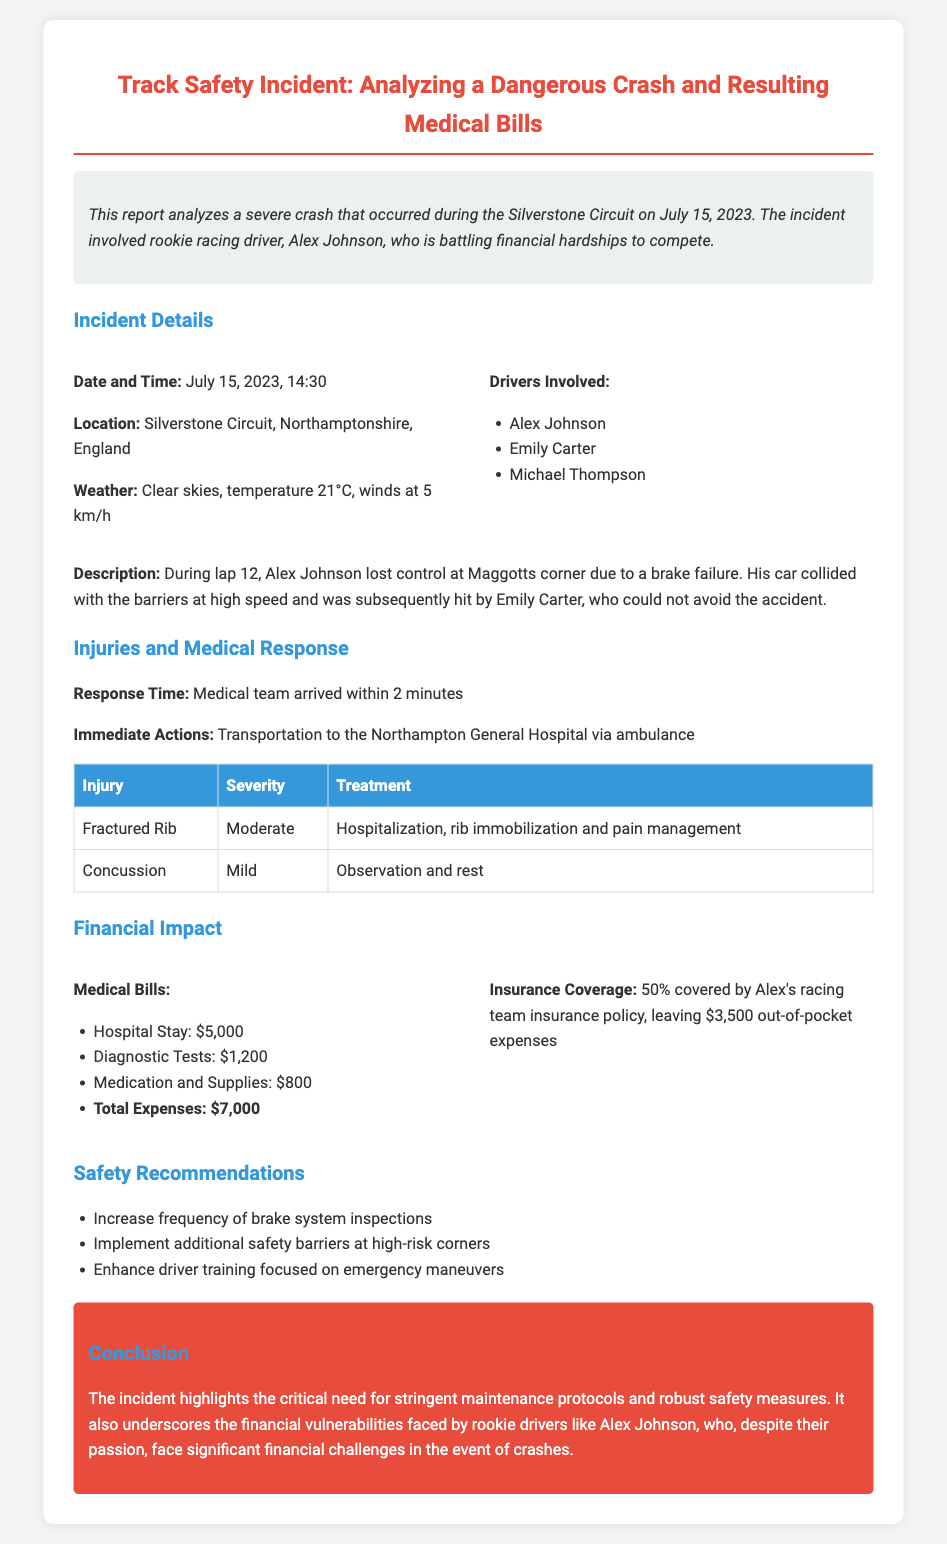What date did the incident occur? The incident took place on July 15, 2023, as stated in the document.
Answer: July 15, 2023 Who was the driver involved in the crash? The document mentions Alex Johnson as the driver who crashed.
Answer: Alex Johnson What injury did Alex Johnson sustain? The report lists a fractured rib as one of Alex Johnson's injuries.
Answer: Fractured Rib What was the response time of the medical team? The document indicates that the medical team arrived within 2 minutes of the incident.
Answer: 2 minutes What is the total out-of-pocket medical expense for Alex? The report states that Alex Johnson has $3,500 in out-of-pocket medical expenses after insurance coverage.
Answer: $3,500 What weather conditions were present during the incident? The weather at the time of the incident was described as clear skies with a temperature of 21°C.
Answer: Clear skies, 21°C What safety recommendation involves brake systems? The report suggests increasing the frequency of brake system inspections as a safety recommendation.
Answer: Increase frequency of brake system inspections What is the total amount of medical bills incurred? The document sums up the medical bills to a total of $7,000.
Answer: $7,000 What corner did the crash occur at? The incident occurred at Maggotts corner, as mentioned in the description.
Answer: Maggotts corner 